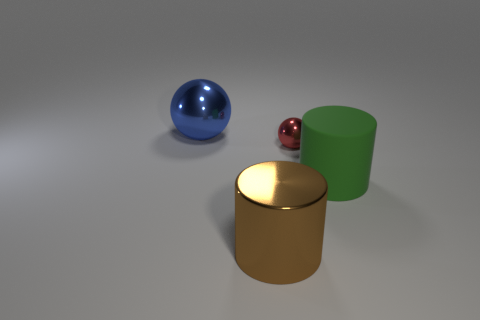If these objects represented a family, what roles might they play based on their size and color? If we use size and color to symbolize a family, we might imagine the large green cylinder as the parent, the gold cylinder as the eldest child, the blue ball as the middle child, and the small red ball as the youngest. 